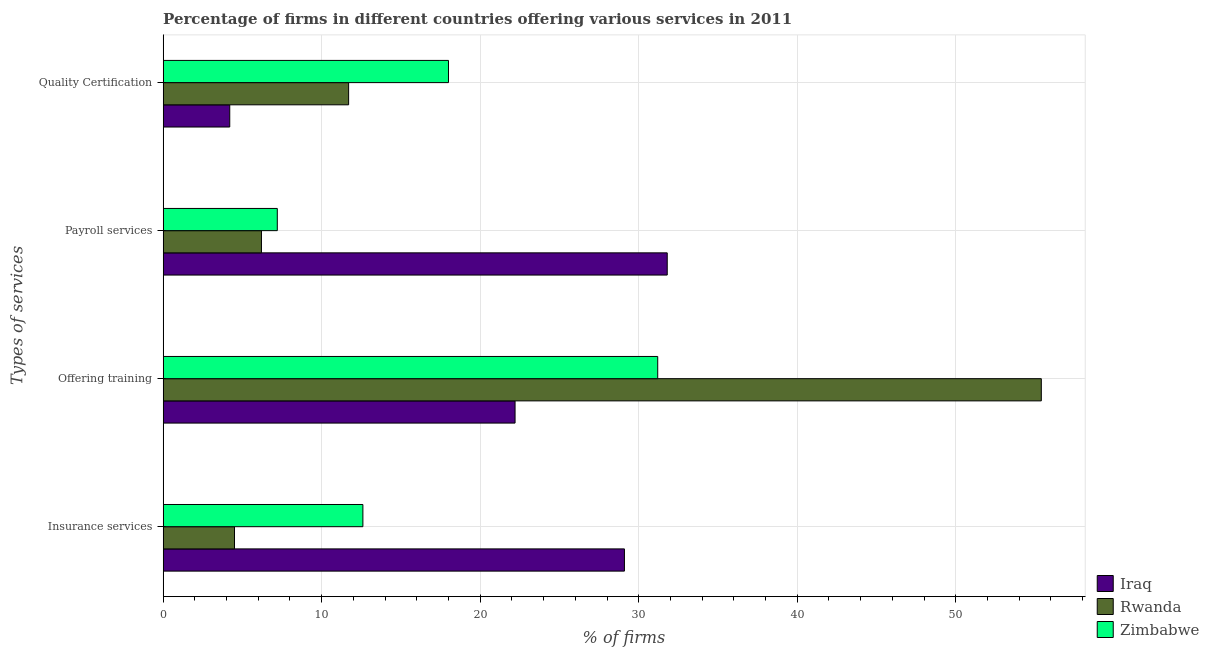How many different coloured bars are there?
Make the answer very short. 3. How many groups of bars are there?
Your response must be concise. 4. How many bars are there on the 4th tick from the bottom?
Your answer should be compact. 3. What is the label of the 4th group of bars from the top?
Provide a short and direct response. Insurance services. What is the percentage of firms offering payroll services in Iraq?
Provide a succinct answer. 31.8. Across all countries, what is the maximum percentage of firms offering payroll services?
Your response must be concise. 31.8. Across all countries, what is the minimum percentage of firms offering insurance services?
Ensure brevity in your answer.  4.5. In which country was the percentage of firms offering quality certification maximum?
Your response must be concise. Zimbabwe. In which country was the percentage of firms offering training minimum?
Provide a short and direct response. Iraq. What is the total percentage of firms offering payroll services in the graph?
Ensure brevity in your answer.  45.2. What is the difference between the percentage of firms offering insurance services in Iraq and that in Rwanda?
Offer a terse response. 24.6. What is the difference between the percentage of firms offering payroll services in Rwanda and the percentage of firms offering training in Zimbabwe?
Ensure brevity in your answer.  -25. What is the average percentage of firms offering insurance services per country?
Your answer should be compact. 15.4. What is the difference between the percentage of firms offering training and percentage of firms offering payroll services in Rwanda?
Provide a short and direct response. 49.2. What is the ratio of the percentage of firms offering payroll services in Zimbabwe to that in Rwanda?
Offer a very short reply. 1.16. What is the difference between the highest and the second highest percentage of firms offering payroll services?
Offer a very short reply. 24.6. What is the difference between the highest and the lowest percentage of firms offering insurance services?
Your response must be concise. 24.6. In how many countries, is the percentage of firms offering insurance services greater than the average percentage of firms offering insurance services taken over all countries?
Offer a terse response. 1. What does the 2nd bar from the top in Payroll services represents?
Offer a very short reply. Rwanda. What does the 3rd bar from the bottom in Quality Certification represents?
Your answer should be very brief. Zimbabwe. Are all the bars in the graph horizontal?
Provide a short and direct response. Yes. How many countries are there in the graph?
Make the answer very short. 3. How many legend labels are there?
Ensure brevity in your answer.  3. What is the title of the graph?
Provide a short and direct response. Percentage of firms in different countries offering various services in 2011. Does "Niger" appear as one of the legend labels in the graph?
Give a very brief answer. No. What is the label or title of the X-axis?
Keep it short and to the point. % of firms. What is the label or title of the Y-axis?
Make the answer very short. Types of services. What is the % of firms in Iraq in Insurance services?
Your answer should be compact. 29.1. What is the % of firms of Rwanda in Insurance services?
Provide a succinct answer. 4.5. What is the % of firms of Iraq in Offering training?
Offer a terse response. 22.2. What is the % of firms of Rwanda in Offering training?
Make the answer very short. 55.4. What is the % of firms in Zimbabwe in Offering training?
Make the answer very short. 31.2. What is the % of firms in Iraq in Payroll services?
Ensure brevity in your answer.  31.8. What is the % of firms in Zimbabwe in Payroll services?
Your answer should be very brief. 7.2. What is the % of firms of Rwanda in Quality Certification?
Make the answer very short. 11.7. Across all Types of services, what is the maximum % of firms of Iraq?
Your response must be concise. 31.8. Across all Types of services, what is the maximum % of firms in Rwanda?
Your response must be concise. 55.4. Across all Types of services, what is the maximum % of firms of Zimbabwe?
Make the answer very short. 31.2. Across all Types of services, what is the minimum % of firms in Rwanda?
Make the answer very short. 4.5. What is the total % of firms of Iraq in the graph?
Your answer should be very brief. 87.3. What is the total % of firms of Rwanda in the graph?
Make the answer very short. 77.8. What is the total % of firms of Zimbabwe in the graph?
Ensure brevity in your answer.  69. What is the difference between the % of firms of Rwanda in Insurance services and that in Offering training?
Keep it short and to the point. -50.9. What is the difference between the % of firms of Zimbabwe in Insurance services and that in Offering training?
Provide a succinct answer. -18.6. What is the difference between the % of firms of Iraq in Insurance services and that in Payroll services?
Your answer should be compact. -2.7. What is the difference between the % of firms in Rwanda in Insurance services and that in Payroll services?
Offer a very short reply. -1.7. What is the difference between the % of firms of Zimbabwe in Insurance services and that in Payroll services?
Your answer should be compact. 5.4. What is the difference between the % of firms in Iraq in Insurance services and that in Quality Certification?
Your answer should be compact. 24.9. What is the difference between the % of firms of Zimbabwe in Insurance services and that in Quality Certification?
Offer a very short reply. -5.4. What is the difference between the % of firms of Iraq in Offering training and that in Payroll services?
Your response must be concise. -9.6. What is the difference between the % of firms of Rwanda in Offering training and that in Payroll services?
Your answer should be very brief. 49.2. What is the difference between the % of firms in Zimbabwe in Offering training and that in Payroll services?
Your answer should be very brief. 24. What is the difference between the % of firms in Rwanda in Offering training and that in Quality Certification?
Offer a terse response. 43.7. What is the difference between the % of firms of Zimbabwe in Offering training and that in Quality Certification?
Give a very brief answer. 13.2. What is the difference between the % of firms of Iraq in Payroll services and that in Quality Certification?
Provide a short and direct response. 27.6. What is the difference between the % of firms of Zimbabwe in Payroll services and that in Quality Certification?
Ensure brevity in your answer.  -10.8. What is the difference between the % of firms of Iraq in Insurance services and the % of firms of Rwanda in Offering training?
Make the answer very short. -26.3. What is the difference between the % of firms of Rwanda in Insurance services and the % of firms of Zimbabwe in Offering training?
Give a very brief answer. -26.7. What is the difference between the % of firms in Iraq in Insurance services and the % of firms in Rwanda in Payroll services?
Make the answer very short. 22.9. What is the difference between the % of firms in Iraq in Insurance services and the % of firms in Zimbabwe in Payroll services?
Give a very brief answer. 21.9. What is the difference between the % of firms of Rwanda in Insurance services and the % of firms of Zimbabwe in Payroll services?
Provide a succinct answer. -2.7. What is the difference between the % of firms of Iraq in Insurance services and the % of firms of Zimbabwe in Quality Certification?
Make the answer very short. 11.1. What is the difference between the % of firms in Rwanda in Insurance services and the % of firms in Zimbabwe in Quality Certification?
Keep it short and to the point. -13.5. What is the difference between the % of firms of Iraq in Offering training and the % of firms of Rwanda in Payroll services?
Keep it short and to the point. 16. What is the difference between the % of firms of Rwanda in Offering training and the % of firms of Zimbabwe in Payroll services?
Your answer should be very brief. 48.2. What is the difference between the % of firms in Iraq in Offering training and the % of firms in Rwanda in Quality Certification?
Offer a very short reply. 10.5. What is the difference between the % of firms of Iraq in Offering training and the % of firms of Zimbabwe in Quality Certification?
Your answer should be compact. 4.2. What is the difference between the % of firms in Rwanda in Offering training and the % of firms in Zimbabwe in Quality Certification?
Offer a very short reply. 37.4. What is the difference between the % of firms in Iraq in Payroll services and the % of firms in Rwanda in Quality Certification?
Offer a very short reply. 20.1. What is the difference between the % of firms of Iraq in Payroll services and the % of firms of Zimbabwe in Quality Certification?
Ensure brevity in your answer.  13.8. What is the difference between the % of firms of Rwanda in Payroll services and the % of firms of Zimbabwe in Quality Certification?
Keep it short and to the point. -11.8. What is the average % of firms in Iraq per Types of services?
Ensure brevity in your answer.  21.82. What is the average % of firms in Rwanda per Types of services?
Your answer should be compact. 19.45. What is the average % of firms in Zimbabwe per Types of services?
Provide a succinct answer. 17.25. What is the difference between the % of firms of Iraq and % of firms of Rwanda in Insurance services?
Keep it short and to the point. 24.6. What is the difference between the % of firms in Iraq and % of firms in Rwanda in Offering training?
Your answer should be very brief. -33.2. What is the difference between the % of firms in Rwanda and % of firms in Zimbabwe in Offering training?
Provide a succinct answer. 24.2. What is the difference between the % of firms of Iraq and % of firms of Rwanda in Payroll services?
Make the answer very short. 25.6. What is the difference between the % of firms of Iraq and % of firms of Zimbabwe in Payroll services?
Keep it short and to the point. 24.6. What is the difference between the % of firms in Iraq and % of firms in Zimbabwe in Quality Certification?
Your answer should be compact. -13.8. What is the ratio of the % of firms in Iraq in Insurance services to that in Offering training?
Give a very brief answer. 1.31. What is the ratio of the % of firms of Rwanda in Insurance services to that in Offering training?
Give a very brief answer. 0.08. What is the ratio of the % of firms in Zimbabwe in Insurance services to that in Offering training?
Make the answer very short. 0.4. What is the ratio of the % of firms in Iraq in Insurance services to that in Payroll services?
Your answer should be compact. 0.92. What is the ratio of the % of firms in Rwanda in Insurance services to that in Payroll services?
Your answer should be very brief. 0.73. What is the ratio of the % of firms in Zimbabwe in Insurance services to that in Payroll services?
Offer a very short reply. 1.75. What is the ratio of the % of firms of Iraq in Insurance services to that in Quality Certification?
Keep it short and to the point. 6.93. What is the ratio of the % of firms in Rwanda in Insurance services to that in Quality Certification?
Make the answer very short. 0.38. What is the ratio of the % of firms of Iraq in Offering training to that in Payroll services?
Your response must be concise. 0.7. What is the ratio of the % of firms of Rwanda in Offering training to that in Payroll services?
Offer a very short reply. 8.94. What is the ratio of the % of firms of Zimbabwe in Offering training to that in Payroll services?
Make the answer very short. 4.33. What is the ratio of the % of firms in Iraq in Offering training to that in Quality Certification?
Give a very brief answer. 5.29. What is the ratio of the % of firms of Rwanda in Offering training to that in Quality Certification?
Provide a short and direct response. 4.74. What is the ratio of the % of firms in Zimbabwe in Offering training to that in Quality Certification?
Offer a terse response. 1.73. What is the ratio of the % of firms of Iraq in Payroll services to that in Quality Certification?
Your response must be concise. 7.57. What is the ratio of the % of firms in Rwanda in Payroll services to that in Quality Certification?
Your response must be concise. 0.53. What is the ratio of the % of firms of Zimbabwe in Payroll services to that in Quality Certification?
Keep it short and to the point. 0.4. What is the difference between the highest and the second highest % of firms in Iraq?
Make the answer very short. 2.7. What is the difference between the highest and the second highest % of firms in Rwanda?
Your answer should be very brief. 43.7. What is the difference between the highest and the second highest % of firms in Zimbabwe?
Offer a terse response. 13.2. What is the difference between the highest and the lowest % of firms of Iraq?
Give a very brief answer. 27.6. What is the difference between the highest and the lowest % of firms of Rwanda?
Your answer should be very brief. 50.9. What is the difference between the highest and the lowest % of firms of Zimbabwe?
Provide a short and direct response. 24. 